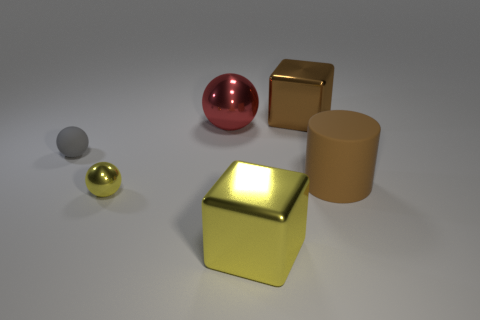How big is the thing that is to the right of the big brown object that is behind the gray rubber ball?
Offer a very short reply. Large. Is there a yellow metallic block that has the same size as the gray matte sphere?
Provide a succinct answer. No. There is a sphere that is made of the same material as the red object; what is its color?
Your answer should be compact. Yellow. Are there fewer tiny green shiny cylinders than yellow things?
Make the answer very short. Yes. There is a object that is both to the left of the brown cube and behind the matte sphere; what is it made of?
Offer a terse response. Metal. Is there a small gray matte object left of the metal ball that is behind the cylinder?
Provide a succinct answer. Yes. What number of rubber cylinders have the same color as the big matte thing?
Ensure brevity in your answer.  0. What is the material of the big block that is the same color as the large cylinder?
Ensure brevity in your answer.  Metal. Is the material of the big yellow block the same as the large brown cube?
Offer a terse response. Yes. Are there any big brown things in front of the brown rubber object?
Make the answer very short. No. 